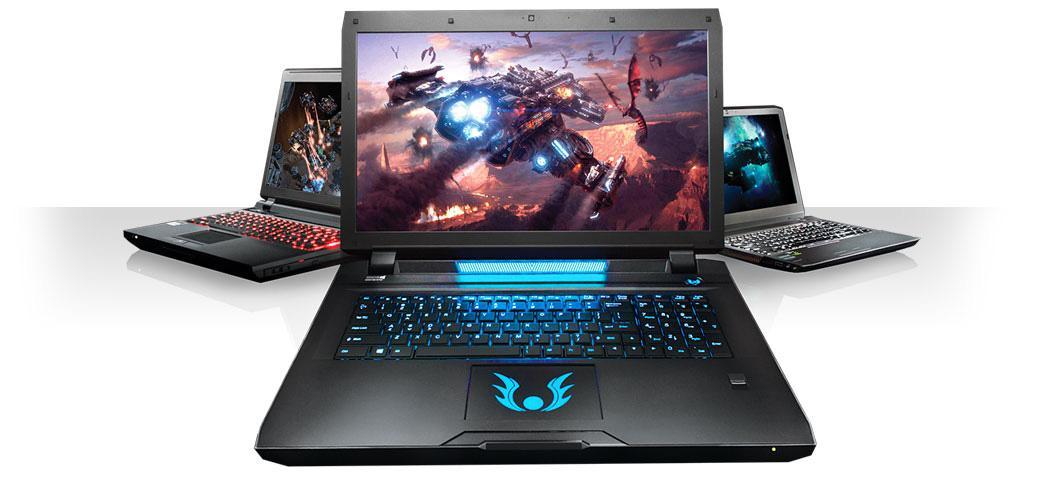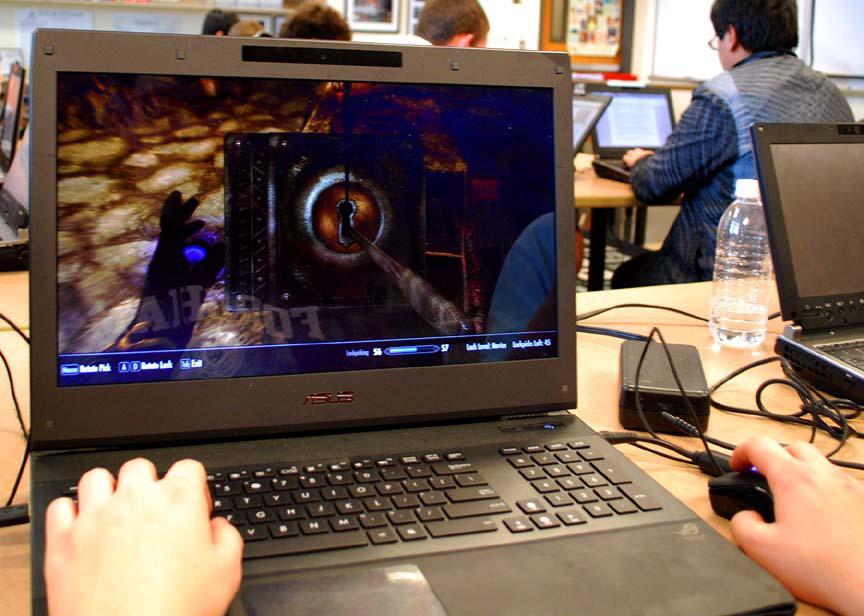The first image is the image on the left, the second image is the image on the right. Analyze the images presented: Is the assertion "A mouse is connected to the computer on the right." valid? Answer yes or no. Yes. The first image is the image on the left, the second image is the image on the right. Considering the images on both sides, is "An image includes a laptop that is facing directly forward." valid? Answer yes or no. Yes. 